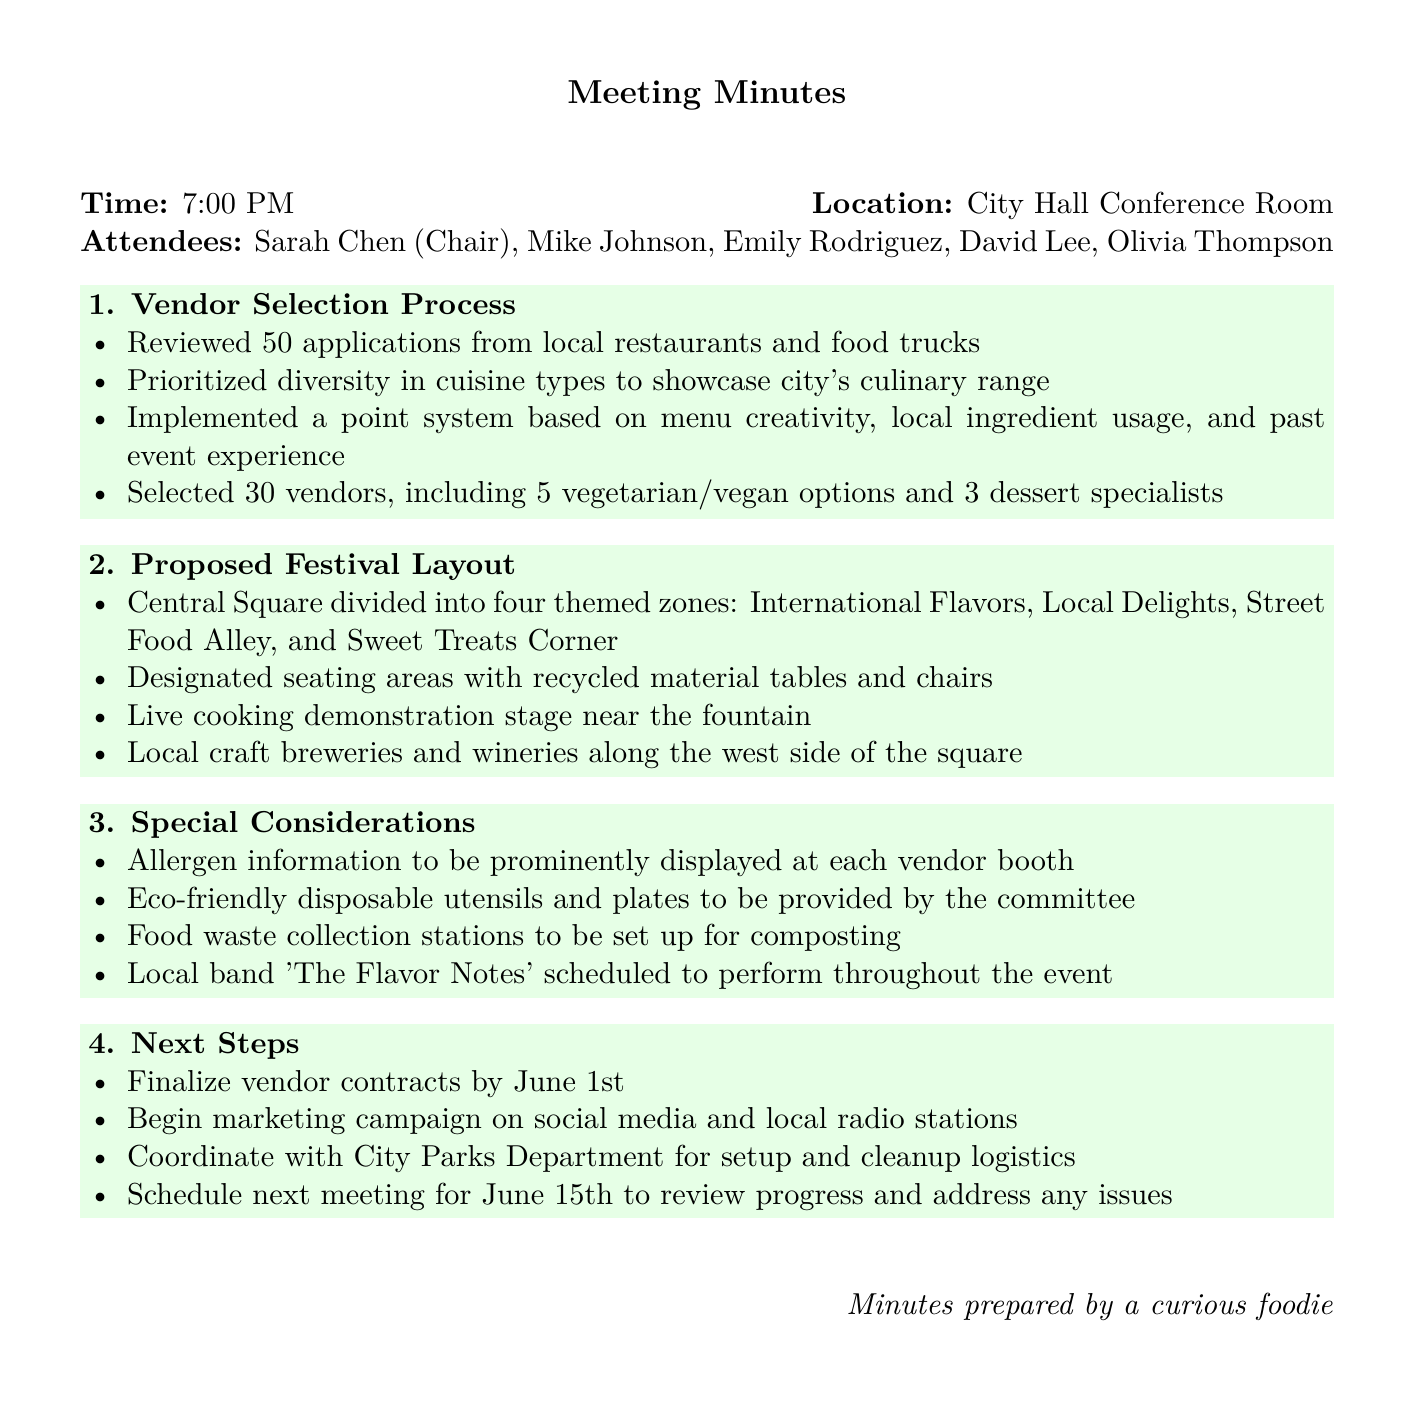what date did the meeting occur? The meeting took place on the date stated in the document, which is May 15, 2023.
Answer: May 15, 2023 how many vendors were selected? The number of vendors selected is mentioned in the document, specifically stated as 30.
Answer: 30 who is the chair of the meeting? The document specifies that Sarah Chen served as the chair of the meeting.
Answer: Sarah Chen what were the four themed zones proposed for the festival? The document outlines the four themed zones, mentioning International Flavors, Local Delights, Street Food Alley, and Sweet Treats Corner.
Answer: International Flavors, Local Delights, Street Food Alley, Sweet Treats Corner what is the next meeting date scheduled for? The document indicates the next meeting is planned for June 15th to discuss progress.
Answer: June 15th why was a point system implemented for vendor selection? The point system was designed to assess menu creativity, local ingredient usage, and past event experience based on the discussion points.
Answer: To assess menu creativity, local ingredient usage, and past event experience who is scheduled to perform at the festival? The document mentions that a local band named 'The Flavor Notes' is scheduled to perform throughout the event.
Answer: The Flavor Notes what type of seating will be used at the festival? The document specifies that seating areas will have recycled material tables and chairs.
Answer: Recycled material tables and chairs 